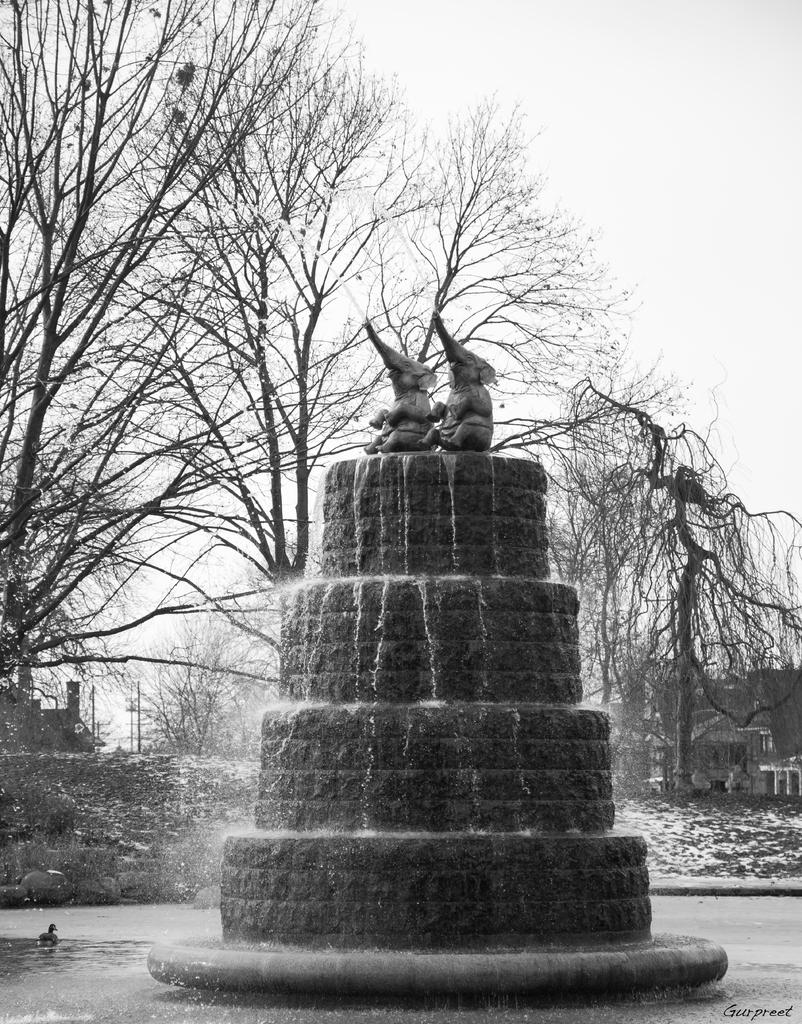What is the main feature in the center of the image? There is a fountain in the center of the image. What can be seen in the background of the image? There are trees in the background of the image. What is visible at the bottom of the image? There is water visible at the bottom of the image. What type of linen is draped over the fountain in the image? There is no linen present in the image; it features a fountain, trees, and water. How does the rock formation in the image compare to the fountain? There is no rock formation mentioned in the provided facts, so it cannot be compared to the fountain. 